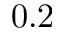<formula> <loc_0><loc_0><loc_500><loc_500>0 . 2</formula> 